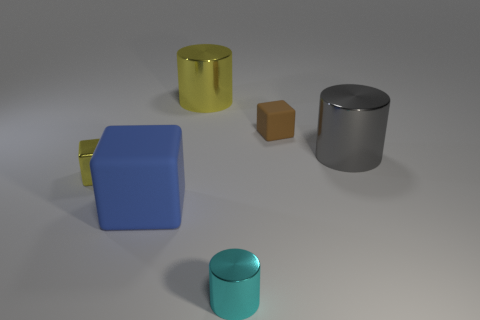Are there any other things that are the same color as the small matte thing? After carefully analyzing the image, it appears that there are no objects that match the exact color of the small matte brown block. The other objects featured—a glossy yellow mug, a matte silver cylinder, a matte blue cube with a glossy handle, and a glossy teal cylinder—are all unique in their color schemes. 